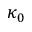<formula> <loc_0><loc_0><loc_500><loc_500>\kappa _ { 0 }</formula> 